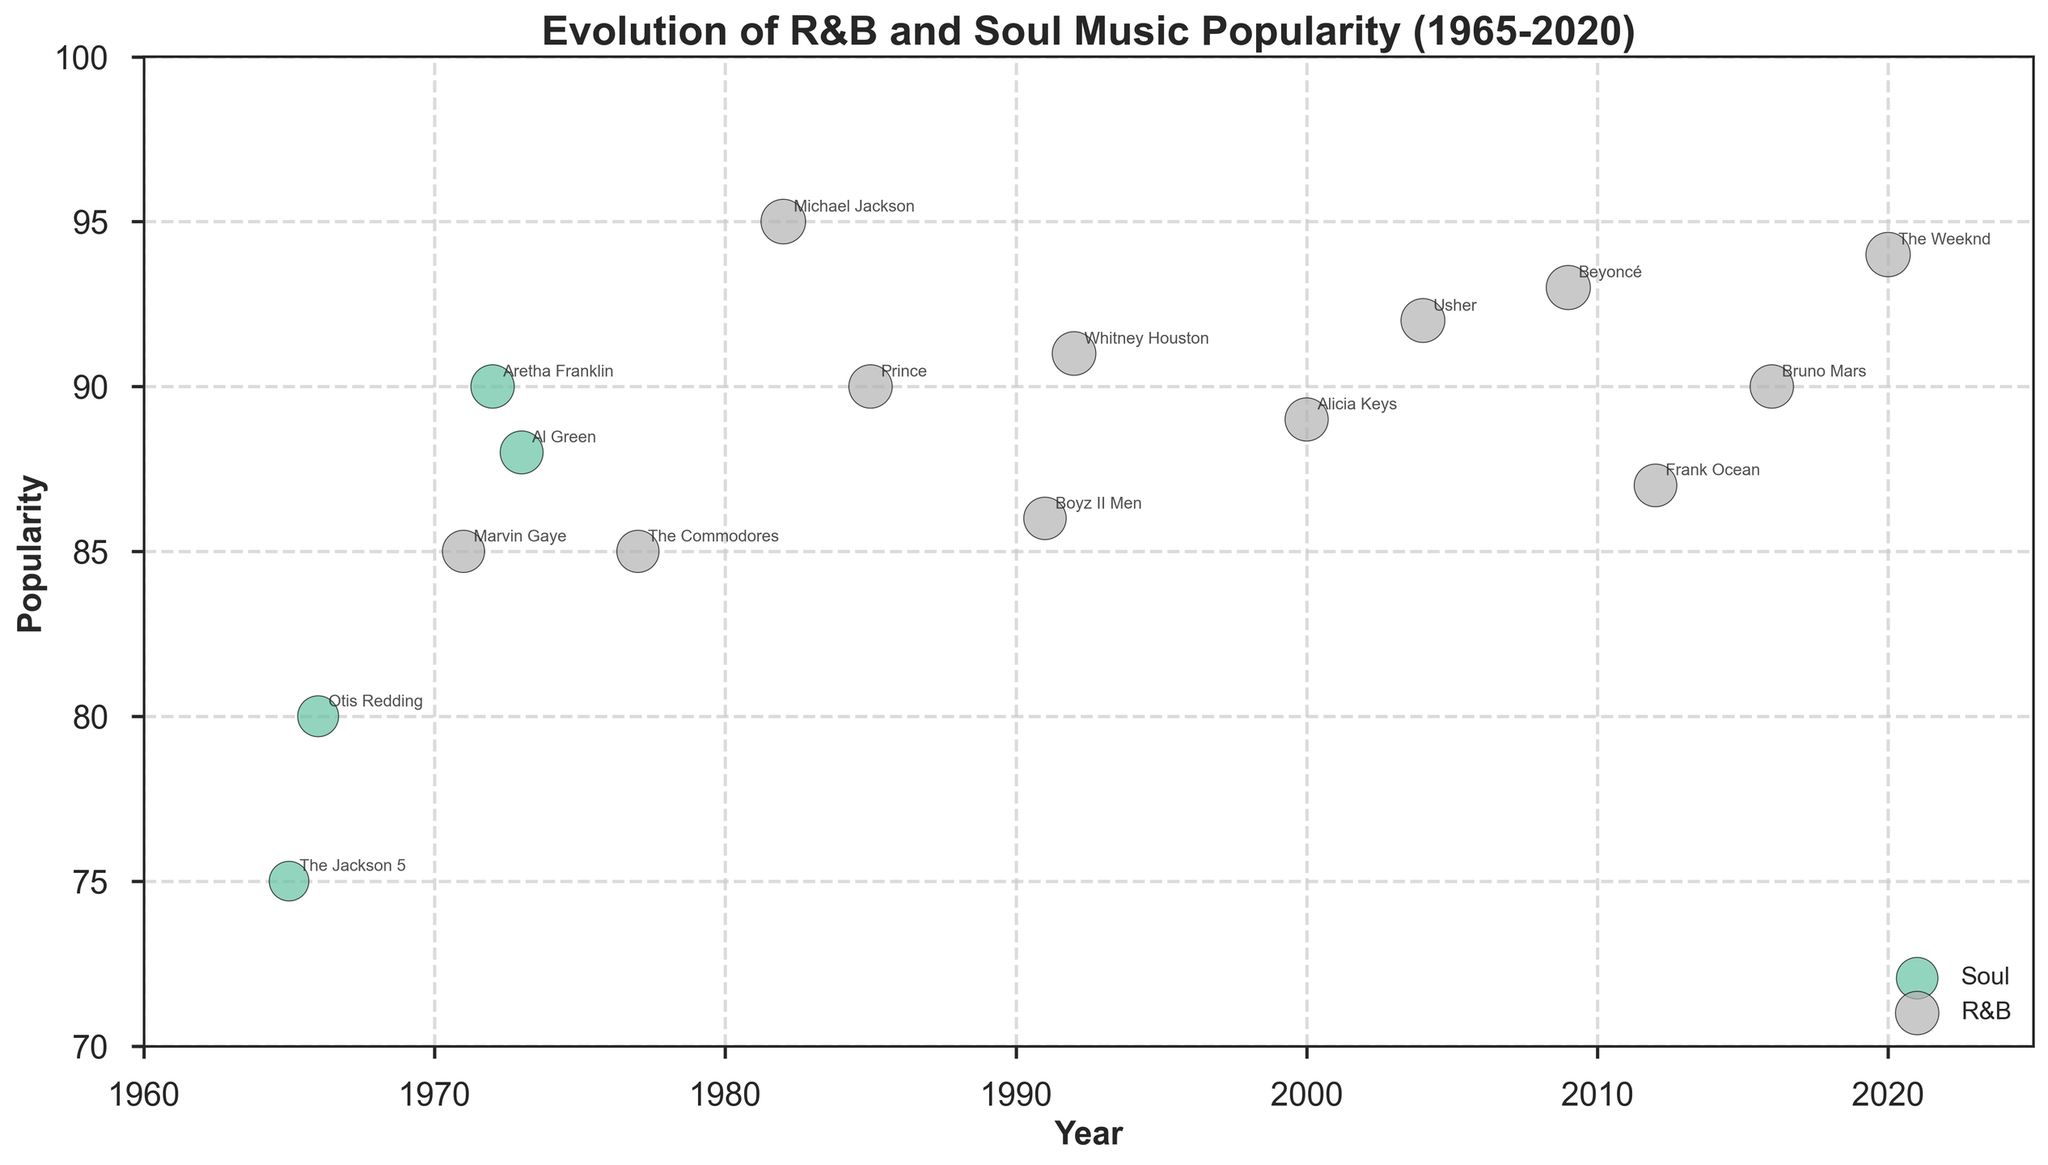What is the title of the plot? The title of the plot is located at the top and can be easily read.
Answer: Evolution of R&B and Soul Music Popularity (1965-2020) Which artist has the highest popularity value on the plot? The artist with the largest data point in terms of size and highest y-axis value is identified.
Answer: Michael Jackson How many genres are represented in the plot? The plot includes two distinct genres displayed in different colors.
Answer: 2 What year does the plot start and end? The plot's x-axis shows the range of years from the start to the end.
Answer: 1965 to 2020 Which genre has more popular artists in the plot, R&B or Soul? Count the number of data points for each genre, noting their respective colors in the plot.
Answer: R&B Between 1980 and 2000, which R&B artist had the highest popularity? Look at the R&B data points within the given year range and select the one with the highest y-axis value.
Answer: Michael Jackson What is the popularity range displayed on the y-axis? The y-axis has labeled ticks indicating the range of popularity scores.
Answer: 70 to 100 Is there any artist whose popularity is annotated more than once? Check if any artist's name appears more than once in different locations.
Answer: No Compare the average popularity of Soul artists with R&B artists in the 1970s. Calculate the average popularity for Soul and R&B artists in the 1970s and compare. For Soul: (Otis Redding + Aretha Franklin + Al Green) = (80 + 90 + 88) / 3 = 86; For R&B: (Marvin Gaye + The Commodores) = (85 + 85) / 2 = 85, so 86 - 85 = 1
Answer: 1 Which years had more annotations for R&B artists versus Soul artists? Count the annotations made per year and compare between genres in those years.
Answer: R&B: 1971, 1977, 1982, 1985, 1991, 1992, 2000, 2004, 2009, 2012, 2016, 2020; Soul: 1965, 1966, 1972, 1973. Hence, more annotations for R&B artists 